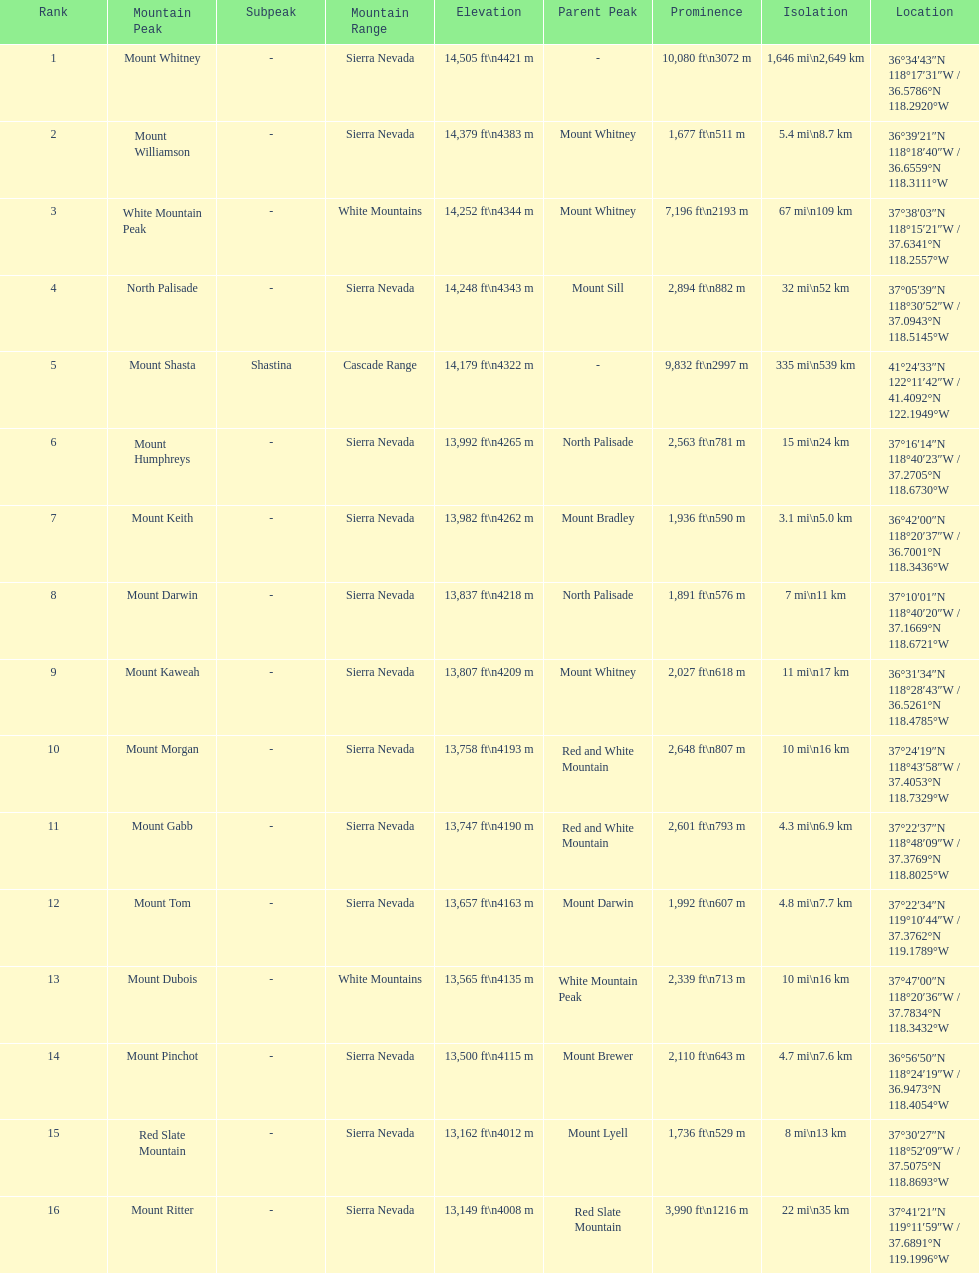Which mountain peak is no higher than 13,149 ft? Mount Ritter. 